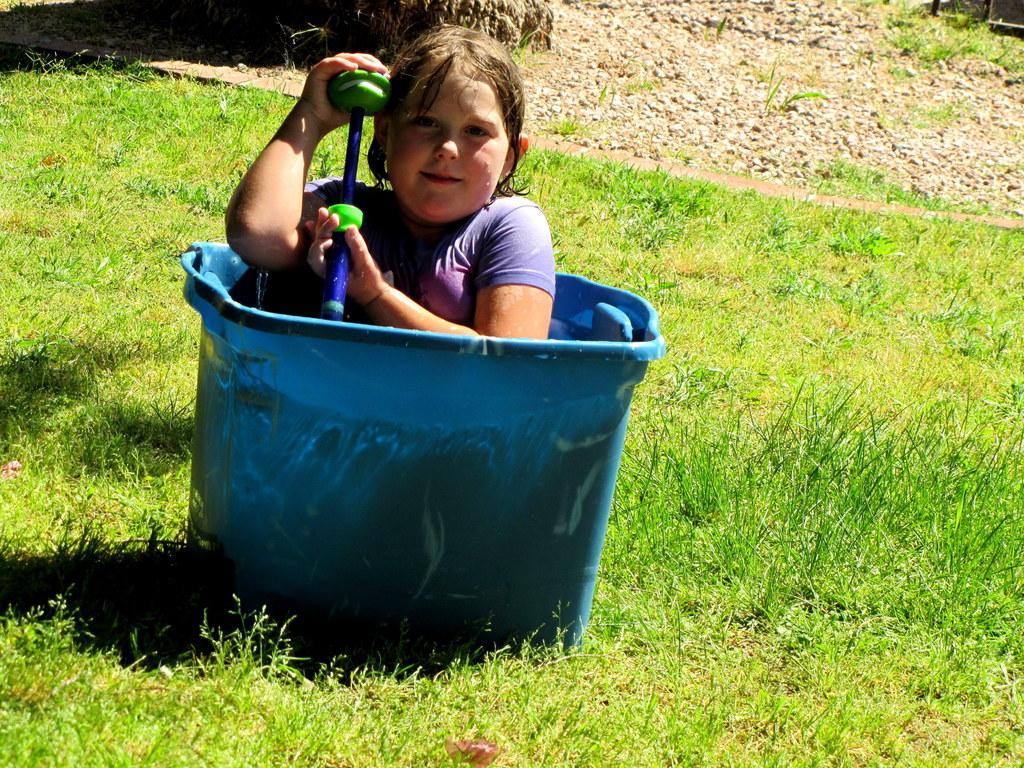Who is the main subject in the image? There is a girl in the image. What is the girl doing in the image? The girl is sitting in a tub. What type of surface is visible at the bottom of the image? There is grass visible at the bottom of the image. What type of milk is the girl drinking in the image? There is no milk present in the image; the girl is sitting in a tub. Can you see any bears in the image? There are no bears present in the image. 